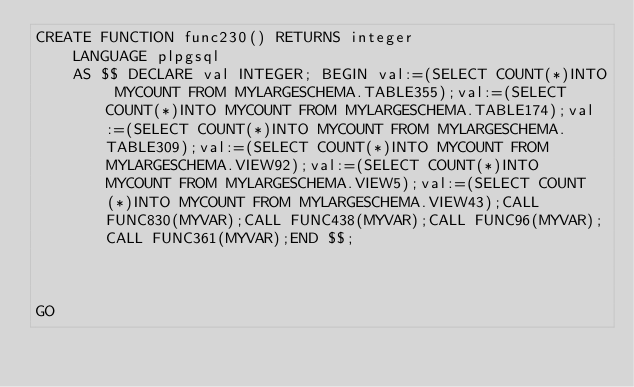<code> <loc_0><loc_0><loc_500><loc_500><_SQL_>CREATE FUNCTION func230() RETURNS integer
    LANGUAGE plpgsql
    AS $$ DECLARE val INTEGER; BEGIN val:=(SELECT COUNT(*)INTO MYCOUNT FROM MYLARGESCHEMA.TABLE355);val:=(SELECT COUNT(*)INTO MYCOUNT FROM MYLARGESCHEMA.TABLE174);val:=(SELECT COUNT(*)INTO MYCOUNT FROM MYLARGESCHEMA.TABLE309);val:=(SELECT COUNT(*)INTO MYCOUNT FROM MYLARGESCHEMA.VIEW92);val:=(SELECT COUNT(*)INTO MYCOUNT FROM MYLARGESCHEMA.VIEW5);val:=(SELECT COUNT(*)INTO MYCOUNT FROM MYLARGESCHEMA.VIEW43);CALL FUNC830(MYVAR);CALL FUNC438(MYVAR);CALL FUNC96(MYVAR);CALL FUNC361(MYVAR);END $$;



GO</code> 